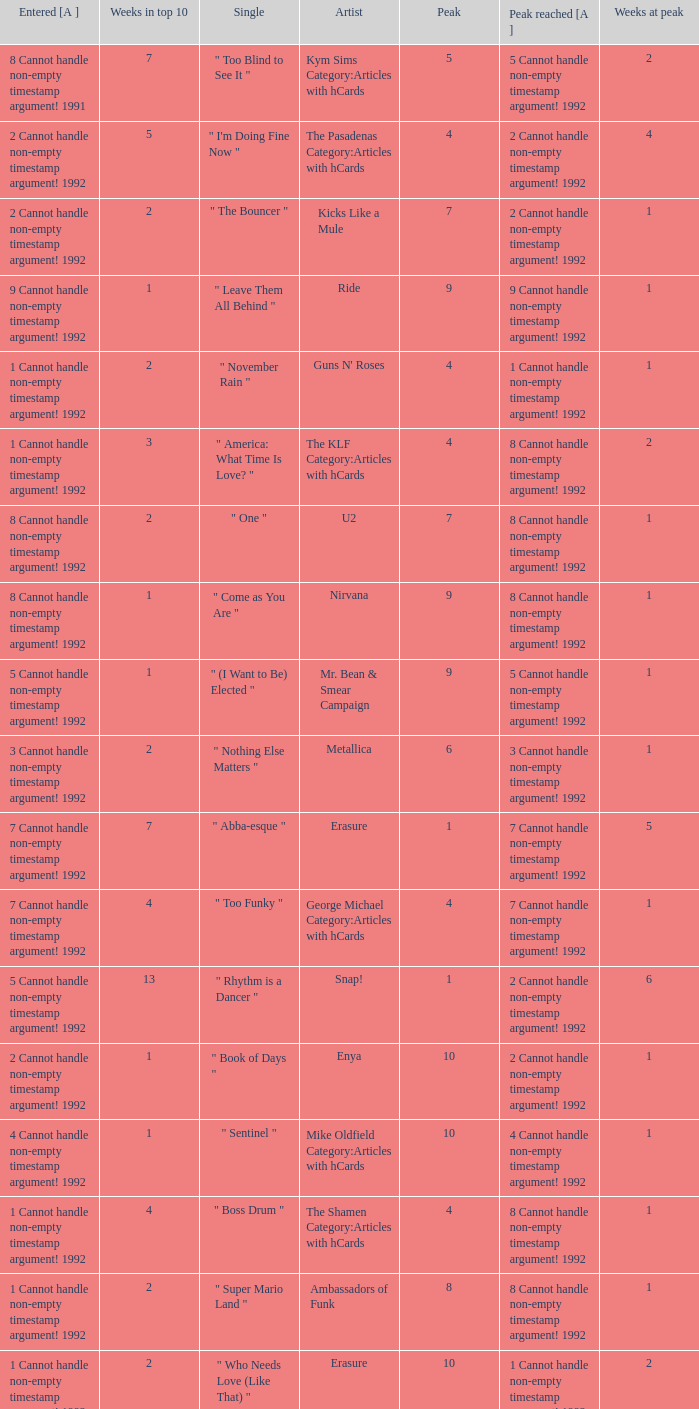In 1992, what was the highest position achieved by a single that spent 4 weeks in the top 10 and entered at number 7 with a non-empty timestamp argument? 7 Cannot handle non-empty timestamp argument! 1992. 